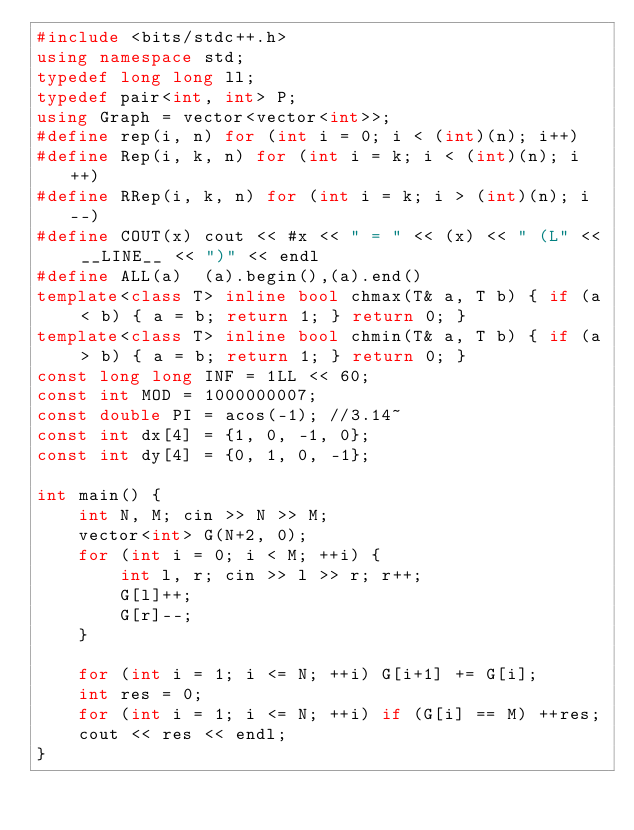Convert code to text. <code><loc_0><loc_0><loc_500><loc_500><_C++_>#include <bits/stdc++.h>
using namespace std;
typedef long long ll;
typedef pair<int, int> P;
using Graph = vector<vector<int>>;
#define rep(i, n) for (int i = 0; i < (int)(n); i++)
#define Rep(i, k, n) for (int i = k; i < (int)(n); i++)
#define RRep(i, k, n) for (int i = k; i > (int)(n); i--)
#define COUT(x) cout << #x << " = " << (x) << " (L" << __LINE__ << ")" << endl
#define ALL(a)  (a).begin(),(a).end()
template<class T> inline bool chmax(T& a, T b) { if (a < b) { a = b; return 1; } return 0; }
template<class T> inline bool chmin(T& a, T b) { if (a > b) { a = b; return 1; } return 0; }
const long long INF = 1LL << 60;
const int MOD = 1000000007;
const double PI = acos(-1); //3.14~
const int dx[4] = {1, 0, -1, 0};
const int dy[4] = {0, 1, 0, -1};

int main() {
    int N, M; cin >> N >> M;
    vector<int> G(N+2, 0);
    for (int i = 0; i < M; ++i) {
        int l, r; cin >> l >> r; r++;
        G[l]++;
        G[r]--;
    }

    for (int i = 1; i <= N; ++i) G[i+1] += G[i];
    int res = 0;
    for (int i = 1; i <= N; ++i) if (G[i] == M) ++res;
    cout << res << endl;
}</code> 